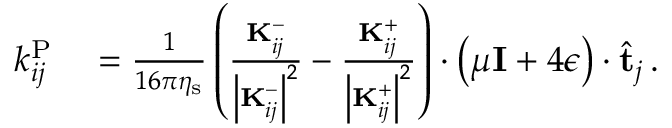<formula> <loc_0><loc_0><loc_500><loc_500>\begin{array} { r l } { k _ { i j } ^ { P } } & = \frac { 1 } { 1 6 \pi \eta _ { s } } \left ( \frac { K _ { i j } ^ { - } } { \left | K _ { i j } ^ { - } \right | ^ { 2 } } - \frac { K _ { i j } ^ { + } } { \left | K _ { i j } ^ { + } \right | ^ { 2 } } \right ) \cdot \left ( \mu I + 4 \epsilon \right ) \cdot \hat { t } _ { j } \, . } \end{array}</formula> 